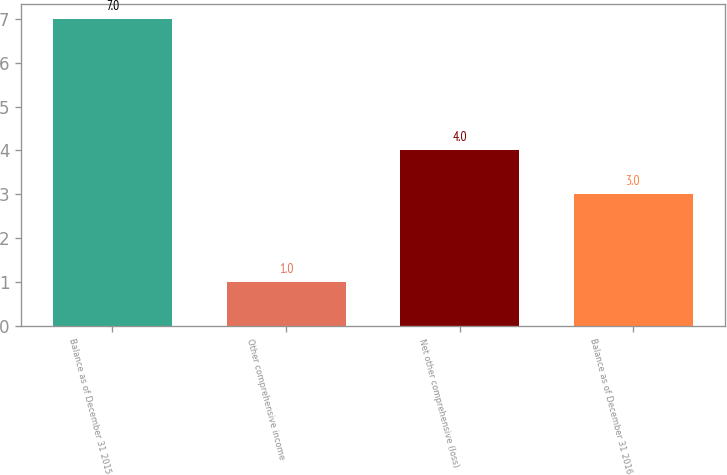Convert chart. <chart><loc_0><loc_0><loc_500><loc_500><bar_chart><fcel>Balance as of December 31 2015<fcel>Other comprehensive income<fcel>Net other comprehensive (loss)<fcel>Balance as of December 31 2016<nl><fcel>7<fcel>1<fcel>4<fcel>3<nl></chart> 